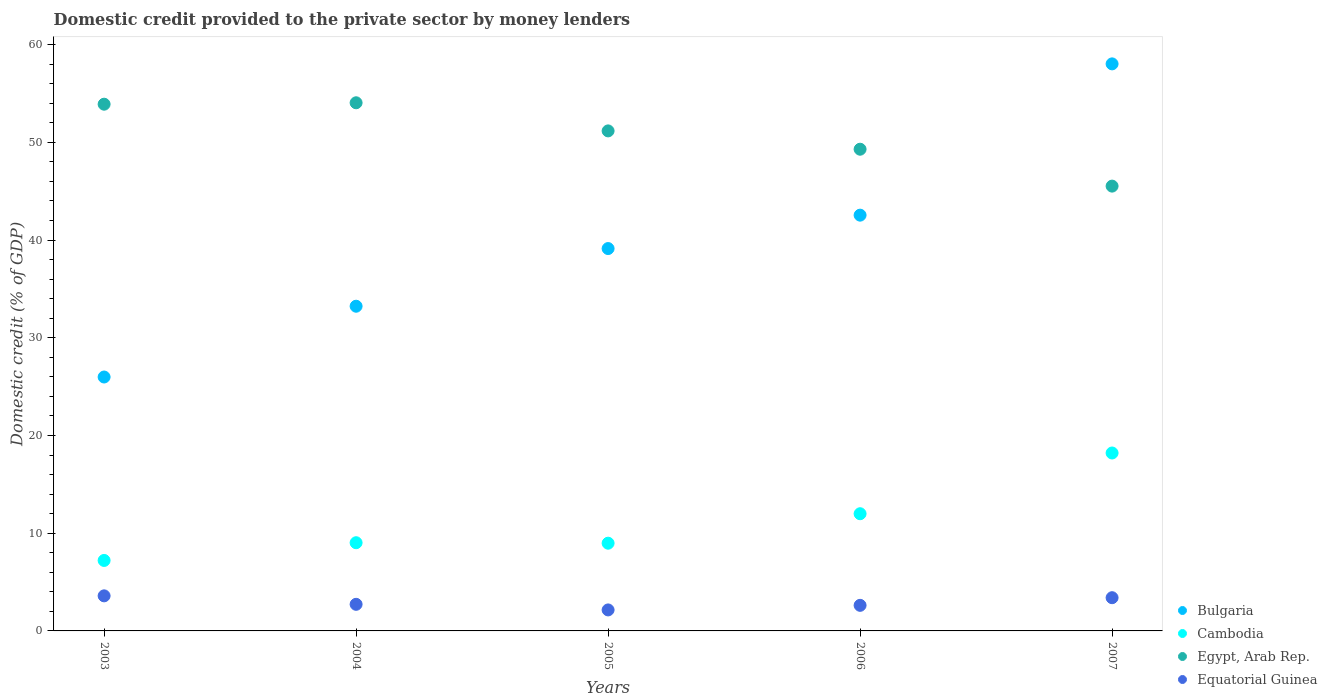How many different coloured dotlines are there?
Keep it short and to the point. 4. What is the domestic credit provided to the private sector by money lenders in Egypt, Arab Rep. in 2006?
Ensure brevity in your answer.  49.29. Across all years, what is the maximum domestic credit provided to the private sector by money lenders in Equatorial Guinea?
Your response must be concise. 3.59. Across all years, what is the minimum domestic credit provided to the private sector by money lenders in Cambodia?
Your answer should be very brief. 7.21. What is the total domestic credit provided to the private sector by money lenders in Equatorial Guinea in the graph?
Provide a succinct answer. 14.48. What is the difference between the domestic credit provided to the private sector by money lenders in Cambodia in 2004 and that in 2007?
Provide a short and direct response. -9.18. What is the difference between the domestic credit provided to the private sector by money lenders in Equatorial Guinea in 2005 and the domestic credit provided to the private sector by money lenders in Cambodia in 2007?
Provide a short and direct response. -16.06. What is the average domestic credit provided to the private sector by money lenders in Equatorial Guinea per year?
Provide a succinct answer. 2.9. In the year 2005, what is the difference between the domestic credit provided to the private sector by money lenders in Cambodia and domestic credit provided to the private sector by money lenders in Egypt, Arab Rep.?
Your answer should be very brief. -42.19. What is the ratio of the domestic credit provided to the private sector by money lenders in Equatorial Guinea in 2003 to that in 2005?
Offer a terse response. 1.67. Is the difference between the domestic credit provided to the private sector by money lenders in Cambodia in 2006 and 2007 greater than the difference between the domestic credit provided to the private sector by money lenders in Egypt, Arab Rep. in 2006 and 2007?
Your answer should be very brief. No. What is the difference between the highest and the second highest domestic credit provided to the private sector by money lenders in Egypt, Arab Rep.?
Your answer should be very brief. 0.15. What is the difference between the highest and the lowest domestic credit provided to the private sector by money lenders in Cambodia?
Offer a terse response. 11. Is it the case that in every year, the sum of the domestic credit provided to the private sector by money lenders in Cambodia and domestic credit provided to the private sector by money lenders in Equatorial Guinea  is greater than the sum of domestic credit provided to the private sector by money lenders in Egypt, Arab Rep. and domestic credit provided to the private sector by money lenders in Bulgaria?
Ensure brevity in your answer.  No. Is it the case that in every year, the sum of the domestic credit provided to the private sector by money lenders in Equatorial Guinea and domestic credit provided to the private sector by money lenders in Cambodia  is greater than the domestic credit provided to the private sector by money lenders in Egypt, Arab Rep.?
Your answer should be very brief. No. Is the domestic credit provided to the private sector by money lenders in Egypt, Arab Rep. strictly greater than the domestic credit provided to the private sector by money lenders in Cambodia over the years?
Give a very brief answer. Yes. How many dotlines are there?
Ensure brevity in your answer.  4. What is the difference between two consecutive major ticks on the Y-axis?
Your response must be concise. 10. Are the values on the major ticks of Y-axis written in scientific E-notation?
Provide a short and direct response. No. How are the legend labels stacked?
Offer a very short reply. Vertical. What is the title of the graph?
Offer a terse response. Domestic credit provided to the private sector by money lenders. Does "Yemen, Rep." appear as one of the legend labels in the graph?
Provide a short and direct response. No. What is the label or title of the X-axis?
Offer a very short reply. Years. What is the label or title of the Y-axis?
Keep it short and to the point. Domestic credit (% of GDP). What is the Domestic credit (% of GDP) in Bulgaria in 2003?
Your response must be concise. 25.98. What is the Domestic credit (% of GDP) of Cambodia in 2003?
Keep it short and to the point. 7.21. What is the Domestic credit (% of GDP) in Egypt, Arab Rep. in 2003?
Offer a very short reply. 53.9. What is the Domestic credit (% of GDP) of Equatorial Guinea in 2003?
Provide a succinct answer. 3.59. What is the Domestic credit (% of GDP) in Bulgaria in 2004?
Offer a terse response. 33.23. What is the Domestic credit (% of GDP) of Cambodia in 2004?
Provide a succinct answer. 9.02. What is the Domestic credit (% of GDP) in Egypt, Arab Rep. in 2004?
Make the answer very short. 54.04. What is the Domestic credit (% of GDP) of Equatorial Guinea in 2004?
Your response must be concise. 2.72. What is the Domestic credit (% of GDP) in Bulgaria in 2005?
Your answer should be compact. 39.13. What is the Domestic credit (% of GDP) of Cambodia in 2005?
Your answer should be compact. 8.98. What is the Domestic credit (% of GDP) in Egypt, Arab Rep. in 2005?
Make the answer very short. 51.17. What is the Domestic credit (% of GDP) in Equatorial Guinea in 2005?
Keep it short and to the point. 2.15. What is the Domestic credit (% of GDP) in Bulgaria in 2006?
Your answer should be very brief. 42.54. What is the Domestic credit (% of GDP) in Cambodia in 2006?
Keep it short and to the point. 11.99. What is the Domestic credit (% of GDP) of Egypt, Arab Rep. in 2006?
Your response must be concise. 49.29. What is the Domestic credit (% of GDP) of Equatorial Guinea in 2006?
Give a very brief answer. 2.62. What is the Domestic credit (% of GDP) of Bulgaria in 2007?
Your answer should be very brief. 58.02. What is the Domestic credit (% of GDP) in Cambodia in 2007?
Your answer should be compact. 18.21. What is the Domestic credit (% of GDP) of Egypt, Arab Rep. in 2007?
Keep it short and to the point. 45.52. What is the Domestic credit (% of GDP) of Equatorial Guinea in 2007?
Your response must be concise. 3.4. Across all years, what is the maximum Domestic credit (% of GDP) of Bulgaria?
Offer a very short reply. 58.02. Across all years, what is the maximum Domestic credit (% of GDP) of Cambodia?
Your answer should be very brief. 18.21. Across all years, what is the maximum Domestic credit (% of GDP) in Egypt, Arab Rep.?
Give a very brief answer. 54.04. Across all years, what is the maximum Domestic credit (% of GDP) in Equatorial Guinea?
Make the answer very short. 3.59. Across all years, what is the minimum Domestic credit (% of GDP) in Bulgaria?
Give a very brief answer. 25.98. Across all years, what is the minimum Domestic credit (% of GDP) of Cambodia?
Your answer should be compact. 7.21. Across all years, what is the minimum Domestic credit (% of GDP) in Egypt, Arab Rep.?
Make the answer very short. 45.52. Across all years, what is the minimum Domestic credit (% of GDP) in Equatorial Guinea?
Offer a very short reply. 2.15. What is the total Domestic credit (% of GDP) in Bulgaria in the graph?
Provide a succinct answer. 198.9. What is the total Domestic credit (% of GDP) in Cambodia in the graph?
Provide a short and direct response. 55.41. What is the total Domestic credit (% of GDP) of Egypt, Arab Rep. in the graph?
Provide a succinct answer. 253.91. What is the total Domestic credit (% of GDP) in Equatorial Guinea in the graph?
Your answer should be very brief. 14.48. What is the difference between the Domestic credit (% of GDP) in Bulgaria in 2003 and that in 2004?
Give a very brief answer. -7.24. What is the difference between the Domestic credit (% of GDP) in Cambodia in 2003 and that in 2004?
Ensure brevity in your answer.  -1.81. What is the difference between the Domestic credit (% of GDP) in Egypt, Arab Rep. in 2003 and that in 2004?
Make the answer very short. -0.15. What is the difference between the Domestic credit (% of GDP) in Equatorial Guinea in 2003 and that in 2004?
Make the answer very short. 0.87. What is the difference between the Domestic credit (% of GDP) of Bulgaria in 2003 and that in 2005?
Provide a succinct answer. -13.14. What is the difference between the Domestic credit (% of GDP) of Cambodia in 2003 and that in 2005?
Your answer should be compact. -1.76. What is the difference between the Domestic credit (% of GDP) of Egypt, Arab Rep. in 2003 and that in 2005?
Offer a terse response. 2.73. What is the difference between the Domestic credit (% of GDP) of Equatorial Guinea in 2003 and that in 2005?
Offer a very short reply. 1.44. What is the difference between the Domestic credit (% of GDP) of Bulgaria in 2003 and that in 2006?
Your answer should be compact. -16.56. What is the difference between the Domestic credit (% of GDP) in Cambodia in 2003 and that in 2006?
Offer a terse response. -4.78. What is the difference between the Domestic credit (% of GDP) in Egypt, Arab Rep. in 2003 and that in 2006?
Your response must be concise. 4.61. What is the difference between the Domestic credit (% of GDP) of Equatorial Guinea in 2003 and that in 2006?
Your answer should be very brief. 0.97. What is the difference between the Domestic credit (% of GDP) of Bulgaria in 2003 and that in 2007?
Your answer should be compact. -32.04. What is the difference between the Domestic credit (% of GDP) of Cambodia in 2003 and that in 2007?
Offer a terse response. -11. What is the difference between the Domestic credit (% of GDP) of Egypt, Arab Rep. in 2003 and that in 2007?
Keep it short and to the point. 8.38. What is the difference between the Domestic credit (% of GDP) in Equatorial Guinea in 2003 and that in 2007?
Keep it short and to the point. 0.19. What is the difference between the Domestic credit (% of GDP) in Bulgaria in 2004 and that in 2005?
Provide a succinct answer. -5.9. What is the difference between the Domestic credit (% of GDP) in Cambodia in 2004 and that in 2005?
Provide a succinct answer. 0.05. What is the difference between the Domestic credit (% of GDP) of Egypt, Arab Rep. in 2004 and that in 2005?
Your response must be concise. 2.88. What is the difference between the Domestic credit (% of GDP) in Equatorial Guinea in 2004 and that in 2005?
Offer a terse response. 0.57. What is the difference between the Domestic credit (% of GDP) in Bulgaria in 2004 and that in 2006?
Provide a short and direct response. -9.32. What is the difference between the Domestic credit (% of GDP) in Cambodia in 2004 and that in 2006?
Provide a succinct answer. -2.97. What is the difference between the Domestic credit (% of GDP) in Egypt, Arab Rep. in 2004 and that in 2006?
Provide a short and direct response. 4.75. What is the difference between the Domestic credit (% of GDP) of Equatorial Guinea in 2004 and that in 2006?
Provide a succinct answer. 0.1. What is the difference between the Domestic credit (% of GDP) in Bulgaria in 2004 and that in 2007?
Provide a short and direct response. -24.8. What is the difference between the Domestic credit (% of GDP) in Cambodia in 2004 and that in 2007?
Provide a short and direct response. -9.18. What is the difference between the Domestic credit (% of GDP) in Egypt, Arab Rep. in 2004 and that in 2007?
Ensure brevity in your answer.  8.53. What is the difference between the Domestic credit (% of GDP) of Equatorial Guinea in 2004 and that in 2007?
Your response must be concise. -0.68. What is the difference between the Domestic credit (% of GDP) in Bulgaria in 2005 and that in 2006?
Your answer should be compact. -3.42. What is the difference between the Domestic credit (% of GDP) of Cambodia in 2005 and that in 2006?
Make the answer very short. -3.02. What is the difference between the Domestic credit (% of GDP) of Egypt, Arab Rep. in 2005 and that in 2006?
Provide a short and direct response. 1.87. What is the difference between the Domestic credit (% of GDP) of Equatorial Guinea in 2005 and that in 2006?
Provide a succinct answer. -0.47. What is the difference between the Domestic credit (% of GDP) of Bulgaria in 2005 and that in 2007?
Ensure brevity in your answer.  -18.9. What is the difference between the Domestic credit (% of GDP) in Cambodia in 2005 and that in 2007?
Keep it short and to the point. -9.23. What is the difference between the Domestic credit (% of GDP) of Egypt, Arab Rep. in 2005 and that in 2007?
Your answer should be compact. 5.65. What is the difference between the Domestic credit (% of GDP) of Equatorial Guinea in 2005 and that in 2007?
Offer a very short reply. -1.25. What is the difference between the Domestic credit (% of GDP) in Bulgaria in 2006 and that in 2007?
Make the answer very short. -15.48. What is the difference between the Domestic credit (% of GDP) of Cambodia in 2006 and that in 2007?
Your answer should be compact. -6.21. What is the difference between the Domestic credit (% of GDP) of Egypt, Arab Rep. in 2006 and that in 2007?
Your response must be concise. 3.78. What is the difference between the Domestic credit (% of GDP) in Equatorial Guinea in 2006 and that in 2007?
Give a very brief answer. -0.78. What is the difference between the Domestic credit (% of GDP) of Bulgaria in 2003 and the Domestic credit (% of GDP) of Cambodia in 2004?
Offer a terse response. 16.96. What is the difference between the Domestic credit (% of GDP) of Bulgaria in 2003 and the Domestic credit (% of GDP) of Egypt, Arab Rep. in 2004?
Your response must be concise. -28.06. What is the difference between the Domestic credit (% of GDP) of Bulgaria in 2003 and the Domestic credit (% of GDP) of Equatorial Guinea in 2004?
Offer a very short reply. 23.26. What is the difference between the Domestic credit (% of GDP) in Cambodia in 2003 and the Domestic credit (% of GDP) in Egypt, Arab Rep. in 2004?
Make the answer very short. -46.83. What is the difference between the Domestic credit (% of GDP) in Cambodia in 2003 and the Domestic credit (% of GDP) in Equatorial Guinea in 2004?
Make the answer very short. 4.49. What is the difference between the Domestic credit (% of GDP) in Egypt, Arab Rep. in 2003 and the Domestic credit (% of GDP) in Equatorial Guinea in 2004?
Your answer should be compact. 51.18. What is the difference between the Domestic credit (% of GDP) of Bulgaria in 2003 and the Domestic credit (% of GDP) of Cambodia in 2005?
Offer a terse response. 17.01. What is the difference between the Domestic credit (% of GDP) in Bulgaria in 2003 and the Domestic credit (% of GDP) in Egypt, Arab Rep. in 2005?
Your response must be concise. -25.18. What is the difference between the Domestic credit (% of GDP) in Bulgaria in 2003 and the Domestic credit (% of GDP) in Equatorial Guinea in 2005?
Offer a terse response. 23.83. What is the difference between the Domestic credit (% of GDP) in Cambodia in 2003 and the Domestic credit (% of GDP) in Egypt, Arab Rep. in 2005?
Ensure brevity in your answer.  -43.95. What is the difference between the Domestic credit (% of GDP) in Cambodia in 2003 and the Domestic credit (% of GDP) in Equatorial Guinea in 2005?
Ensure brevity in your answer.  5.06. What is the difference between the Domestic credit (% of GDP) of Egypt, Arab Rep. in 2003 and the Domestic credit (% of GDP) of Equatorial Guinea in 2005?
Offer a terse response. 51.75. What is the difference between the Domestic credit (% of GDP) of Bulgaria in 2003 and the Domestic credit (% of GDP) of Cambodia in 2006?
Ensure brevity in your answer.  13.99. What is the difference between the Domestic credit (% of GDP) of Bulgaria in 2003 and the Domestic credit (% of GDP) of Egypt, Arab Rep. in 2006?
Offer a very short reply. -23.31. What is the difference between the Domestic credit (% of GDP) of Bulgaria in 2003 and the Domestic credit (% of GDP) of Equatorial Guinea in 2006?
Your response must be concise. 23.36. What is the difference between the Domestic credit (% of GDP) in Cambodia in 2003 and the Domestic credit (% of GDP) in Egypt, Arab Rep. in 2006?
Make the answer very short. -42.08. What is the difference between the Domestic credit (% of GDP) of Cambodia in 2003 and the Domestic credit (% of GDP) of Equatorial Guinea in 2006?
Your answer should be very brief. 4.59. What is the difference between the Domestic credit (% of GDP) of Egypt, Arab Rep. in 2003 and the Domestic credit (% of GDP) of Equatorial Guinea in 2006?
Keep it short and to the point. 51.28. What is the difference between the Domestic credit (% of GDP) of Bulgaria in 2003 and the Domestic credit (% of GDP) of Cambodia in 2007?
Your response must be concise. 7.77. What is the difference between the Domestic credit (% of GDP) in Bulgaria in 2003 and the Domestic credit (% of GDP) in Egypt, Arab Rep. in 2007?
Your response must be concise. -19.53. What is the difference between the Domestic credit (% of GDP) in Bulgaria in 2003 and the Domestic credit (% of GDP) in Equatorial Guinea in 2007?
Make the answer very short. 22.58. What is the difference between the Domestic credit (% of GDP) of Cambodia in 2003 and the Domestic credit (% of GDP) of Egypt, Arab Rep. in 2007?
Make the answer very short. -38.3. What is the difference between the Domestic credit (% of GDP) in Cambodia in 2003 and the Domestic credit (% of GDP) in Equatorial Guinea in 2007?
Keep it short and to the point. 3.81. What is the difference between the Domestic credit (% of GDP) in Egypt, Arab Rep. in 2003 and the Domestic credit (% of GDP) in Equatorial Guinea in 2007?
Offer a very short reply. 50.5. What is the difference between the Domestic credit (% of GDP) in Bulgaria in 2004 and the Domestic credit (% of GDP) in Cambodia in 2005?
Provide a short and direct response. 24.25. What is the difference between the Domestic credit (% of GDP) in Bulgaria in 2004 and the Domestic credit (% of GDP) in Egypt, Arab Rep. in 2005?
Provide a short and direct response. -17.94. What is the difference between the Domestic credit (% of GDP) of Bulgaria in 2004 and the Domestic credit (% of GDP) of Equatorial Guinea in 2005?
Your answer should be compact. 31.08. What is the difference between the Domestic credit (% of GDP) in Cambodia in 2004 and the Domestic credit (% of GDP) in Egypt, Arab Rep. in 2005?
Your response must be concise. -42.14. What is the difference between the Domestic credit (% of GDP) of Cambodia in 2004 and the Domestic credit (% of GDP) of Equatorial Guinea in 2005?
Provide a short and direct response. 6.88. What is the difference between the Domestic credit (% of GDP) in Egypt, Arab Rep. in 2004 and the Domestic credit (% of GDP) in Equatorial Guinea in 2005?
Provide a succinct answer. 51.89. What is the difference between the Domestic credit (% of GDP) in Bulgaria in 2004 and the Domestic credit (% of GDP) in Cambodia in 2006?
Your answer should be compact. 21.23. What is the difference between the Domestic credit (% of GDP) of Bulgaria in 2004 and the Domestic credit (% of GDP) of Egypt, Arab Rep. in 2006?
Provide a short and direct response. -16.07. What is the difference between the Domestic credit (% of GDP) in Bulgaria in 2004 and the Domestic credit (% of GDP) in Equatorial Guinea in 2006?
Your response must be concise. 30.61. What is the difference between the Domestic credit (% of GDP) of Cambodia in 2004 and the Domestic credit (% of GDP) of Egypt, Arab Rep. in 2006?
Keep it short and to the point. -40.27. What is the difference between the Domestic credit (% of GDP) in Cambodia in 2004 and the Domestic credit (% of GDP) in Equatorial Guinea in 2006?
Provide a succinct answer. 6.41. What is the difference between the Domestic credit (% of GDP) in Egypt, Arab Rep. in 2004 and the Domestic credit (% of GDP) in Equatorial Guinea in 2006?
Give a very brief answer. 51.43. What is the difference between the Domestic credit (% of GDP) in Bulgaria in 2004 and the Domestic credit (% of GDP) in Cambodia in 2007?
Ensure brevity in your answer.  15.02. What is the difference between the Domestic credit (% of GDP) of Bulgaria in 2004 and the Domestic credit (% of GDP) of Egypt, Arab Rep. in 2007?
Offer a terse response. -12.29. What is the difference between the Domestic credit (% of GDP) in Bulgaria in 2004 and the Domestic credit (% of GDP) in Equatorial Guinea in 2007?
Your response must be concise. 29.83. What is the difference between the Domestic credit (% of GDP) of Cambodia in 2004 and the Domestic credit (% of GDP) of Egypt, Arab Rep. in 2007?
Offer a very short reply. -36.49. What is the difference between the Domestic credit (% of GDP) of Cambodia in 2004 and the Domestic credit (% of GDP) of Equatorial Guinea in 2007?
Offer a very short reply. 5.63. What is the difference between the Domestic credit (% of GDP) of Egypt, Arab Rep. in 2004 and the Domestic credit (% of GDP) of Equatorial Guinea in 2007?
Your answer should be compact. 50.64. What is the difference between the Domestic credit (% of GDP) in Bulgaria in 2005 and the Domestic credit (% of GDP) in Cambodia in 2006?
Offer a very short reply. 27.13. What is the difference between the Domestic credit (% of GDP) in Bulgaria in 2005 and the Domestic credit (% of GDP) in Egypt, Arab Rep. in 2006?
Provide a succinct answer. -10.17. What is the difference between the Domestic credit (% of GDP) of Bulgaria in 2005 and the Domestic credit (% of GDP) of Equatorial Guinea in 2006?
Offer a very short reply. 36.51. What is the difference between the Domestic credit (% of GDP) of Cambodia in 2005 and the Domestic credit (% of GDP) of Egypt, Arab Rep. in 2006?
Offer a terse response. -40.31. What is the difference between the Domestic credit (% of GDP) of Cambodia in 2005 and the Domestic credit (% of GDP) of Equatorial Guinea in 2006?
Offer a terse response. 6.36. What is the difference between the Domestic credit (% of GDP) in Egypt, Arab Rep. in 2005 and the Domestic credit (% of GDP) in Equatorial Guinea in 2006?
Your answer should be compact. 48.55. What is the difference between the Domestic credit (% of GDP) in Bulgaria in 2005 and the Domestic credit (% of GDP) in Cambodia in 2007?
Offer a terse response. 20.92. What is the difference between the Domestic credit (% of GDP) of Bulgaria in 2005 and the Domestic credit (% of GDP) of Egypt, Arab Rep. in 2007?
Provide a short and direct response. -6.39. What is the difference between the Domestic credit (% of GDP) of Bulgaria in 2005 and the Domestic credit (% of GDP) of Equatorial Guinea in 2007?
Keep it short and to the point. 35.73. What is the difference between the Domestic credit (% of GDP) of Cambodia in 2005 and the Domestic credit (% of GDP) of Egypt, Arab Rep. in 2007?
Provide a succinct answer. -36.54. What is the difference between the Domestic credit (% of GDP) in Cambodia in 2005 and the Domestic credit (% of GDP) in Equatorial Guinea in 2007?
Your answer should be very brief. 5.58. What is the difference between the Domestic credit (% of GDP) of Egypt, Arab Rep. in 2005 and the Domestic credit (% of GDP) of Equatorial Guinea in 2007?
Give a very brief answer. 47.77. What is the difference between the Domestic credit (% of GDP) of Bulgaria in 2006 and the Domestic credit (% of GDP) of Cambodia in 2007?
Provide a short and direct response. 24.34. What is the difference between the Domestic credit (% of GDP) of Bulgaria in 2006 and the Domestic credit (% of GDP) of Egypt, Arab Rep. in 2007?
Your response must be concise. -2.97. What is the difference between the Domestic credit (% of GDP) in Bulgaria in 2006 and the Domestic credit (% of GDP) in Equatorial Guinea in 2007?
Give a very brief answer. 39.14. What is the difference between the Domestic credit (% of GDP) of Cambodia in 2006 and the Domestic credit (% of GDP) of Egypt, Arab Rep. in 2007?
Provide a succinct answer. -33.52. What is the difference between the Domestic credit (% of GDP) of Cambodia in 2006 and the Domestic credit (% of GDP) of Equatorial Guinea in 2007?
Provide a succinct answer. 8.59. What is the difference between the Domestic credit (% of GDP) of Egypt, Arab Rep. in 2006 and the Domestic credit (% of GDP) of Equatorial Guinea in 2007?
Your answer should be very brief. 45.89. What is the average Domestic credit (% of GDP) of Bulgaria per year?
Make the answer very short. 39.78. What is the average Domestic credit (% of GDP) in Cambodia per year?
Provide a succinct answer. 11.08. What is the average Domestic credit (% of GDP) of Egypt, Arab Rep. per year?
Keep it short and to the point. 50.78. What is the average Domestic credit (% of GDP) in Equatorial Guinea per year?
Offer a terse response. 2.9. In the year 2003, what is the difference between the Domestic credit (% of GDP) in Bulgaria and Domestic credit (% of GDP) in Cambodia?
Offer a terse response. 18.77. In the year 2003, what is the difference between the Domestic credit (% of GDP) of Bulgaria and Domestic credit (% of GDP) of Egypt, Arab Rep.?
Your answer should be very brief. -27.92. In the year 2003, what is the difference between the Domestic credit (% of GDP) in Bulgaria and Domestic credit (% of GDP) in Equatorial Guinea?
Your answer should be compact. 22.39. In the year 2003, what is the difference between the Domestic credit (% of GDP) of Cambodia and Domestic credit (% of GDP) of Egypt, Arab Rep.?
Provide a short and direct response. -46.69. In the year 2003, what is the difference between the Domestic credit (% of GDP) in Cambodia and Domestic credit (% of GDP) in Equatorial Guinea?
Your answer should be very brief. 3.62. In the year 2003, what is the difference between the Domestic credit (% of GDP) of Egypt, Arab Rep. and Domestic credit (% of GDP) of Equatorial Guinea?
Offer a terse response. 50.31. In the year 2004, what is the difference between the Domestic credit (% of GDP) of Bulgaria and Domestic credit (% of GDP) of Cambodia?
Keep it short and to the point. 24.2. In the year 2004, what is the difference between the Domestic credit (% of GDP) in Bulgaria and Domestic credit (% of GDP) in Egypt, Arab Rep.?
Your answer should be compact. -20.82. In the year 2004, what is the difference between the Domestic credit (% of GDP) in Bulgaria and Domestic credit (% of GDP) in Equatorial Guinea?
Make the answer very short. 30.5. In the year 2004, what is the difference between the Domestic credit (% of GDP) of Cambodia and Domestic credit (% of GDP) of Egypt, Arab Rep.?
Give a very brief answer. -45.02. In the year 2004, what is the difference between the Domestic credit (% of GDP) of Cambodia and Domestic credit (% of GDP) of Equatorial Guinea?
Make the answer very short. 6.3. In the year 2004, what is the difference between the Domestic credit (% of GDP) of Egypt, Arab Rep. and Domestic credit (% of GDP) of Equatorial Guinea?
Offer a very short reply. 51.32. In the year 2005, what is the difference between the Domestic credit (% of GDP) of Bulgaria and Domestic credit (% of GDP) of Cambodia?
Your answer should be very brief. 30.15. In the year 2005, what is the difference between the Domestic credit (% of GDP) in Bulgaria and Domestic credit (% of GDP) in Egypt, Arab Rep.?
Make the answer very short. -12.04. In the year 2005, what is the difference between the Domestic credit (% of GDP) of Bulgaria and Domestic credit (% of GDP) of Equatorial Guinea?
Give a very brief answer. 36.98. In the year 2005, what is the difference between the Domestic credit (% of GDP) of Cambodia and Domestic credit (% of GDP) of Egypt, Arab Rep.?
Your answer should be compact. -42.19. In the year 2005, what is the difference between the Domestic credit (% of GDP) in Cambodia and Domestic credit (% of GDP) in Equatorial Guinea?
Keep it short and to the point. 6.83. In the year 2005, what is the difference between the Domestic credit (% of GDP) of Egypt, Arab Rep. and Domestic credit (% of GDP) of Equatorial Guinea?
Your response must be concise. 49.02. In the year 2006, what is the difference between the Domestic credit (% of GDP) of Bulgaria and Domestic credit (% of GDP) of Cambodia?
Your answer should be very brief. 30.55. In the year 2006, what is the difference between the Domestic credit (% of GDP) in Bulgaria and Domestic credit (% of GDP) in Egypt, Arab Rep.?
Make the answer very short. -6.75. In the year 2006, what is the difference between the Domestic credit (% of GDP) in Bulgaria and Domestic credit (% of GDP) in Equatorial Guinea?
Your answer should be very brief. 39.93. In the year 2006, what is the difference between the Domestic credit (% of GDP) of Cambodia and Domestic credit (% of GDP) of Egypt, Arab Rep.?
Provide a succinct answer. -37.3. In the year 2006, what is the difference between the Domestic credit (% of GDP) in Cambodia and Domestic credit (% of GDP) in Equatorial Guinea?
Keep it short and to the point. 9.38. In the year 2006, what is the difference between the Domestic credit (% of GDP) of Egypt, Arab Rep. and Domestic credit (% of GDP) of Equatorial Guinea?
Provide a short and direct response. 46.67. In the year 2007, what is the difference between the Domestic credit (% of GDP) in Bulgaria and Domestic credit (% of GDP) in Cambodia?
Provide a succinct answer. 39.82. In the year 2007, what is the difference between the Domestic credit (% of GDP) of Bulgaria and Domestic credit (% of GDP) of Egypt, Arab Rep.?
Your answer should be very brief. 12.51. In the year 2007, what is the difference between the Domestic credit (% of GDP) of Bulgaria and Domestic credit (% of GDP) of Equatorial Guinea?
Keep it short and to the point. 54.62. In the year 2007, what is the difference between the Domestic credit (% of GDP) in Cambodia and Domestic credit (% of GDP) in Egypt, Arab Rep.?
Your answer should be compact. -27.31. In the year 2007, what is the difference between the Domestic credit (% of GDP) of Cambodia and Domestic credit (% of GDP) of Equatorial Guinea?
Provide a succinct answer. 14.81. In the year 2007, what is the difference between the Domestic credit (% of GDP) in Egypt, Arab Rep. and Domestic credit (% of GDP) in Equatorial Guinea?
Your answer should be very brief. 42.12. What is the ratio of the Domestic credit (% of GDP) in Bulgaria in 2003 to that in 2004?
Provide a succinct answer. 0.78. What is the ratio of the Domestic credit (% of GDP) of Cambodia in 2003 to that in 2004?
Offer a terse response. 0.8. What is the ratio of the Domestic credit (% of GDP) in Equatorial Guinea in 2003 to that in 2004?
Make the answer very short. 1.32. What is the ratio of the Domestic credit (% of GDP) in Bulgaria in 2003 to that in 2005?
Provide a short and direct response. 0.66. What is the ratio of the Domestic credit (% of GDP) in Cambodia in 2003 to that in 2005?
Your answer should be compact. 0.8. What is the ratio of the Domestic credit (% of GDP) of Egypt, Arab Rep. in 2003 to that in 2005?
Make the answer very short. 1.05. What is the ratio of the Domestic credit (% of GDP) in Equatorial Guinea in 2003 to that in 2005?
Keep it short and to the point. 1.67. What is the ratio of the Domestic credit (% of GDP) in Bulgaria in 2003 to that in 2006?
Your answer should be compact. 0.61. What is the ratio of the Domestic credit (% of GDP) of Cambodia in 2003 to that in 2006?
Offer a very short reply. 0.6. What is the ratio of the Domestic credit (% of GDP) of Egypt, Arab Rep. in 2003 to that in 2006?
Your response must be concise. 1.09. What is the ratio of the Domestic credit (% of GDP) in Equatorial Guinea in 2003 to that in 2006?
Offer a terse response. 1.37. What is the ratio of the Domestic credit (% of GDP) of Bulgaria in 2003 to that in 2007?
Offer a terse response. 0.45. What is the ratio of the Domestic credit (% of GDP) in Cambodia in 2003 to that in 2007?
Offer a very short reply. 0.4. What is the ratio of the Domestic credit (% of GDP) in Egypt, Arab Rep. in 2003 to that in 2007?
Ensure brevity in your answer.  1.18. What is the ratio of the Domestic credit (% of GDP) of Equatorial Guinea in 2003 to that in 2007?
Ensure brevity in your answer.  1.06. What is the ratio of the Domestic credit (% of GDP) in Bulgaria in 2004 to that in 2005?
Make the answer very short. 0.85. What is the ratio of the Domestic credit (% of GDP) in Cambodia in 2004 to that in 2005?
Offer a very short reply. 1.01. What is the ratio of the Domestic credit (% of GDP) of Egypt, Arab Rep. in 2004 to that in 2005?
Provide a short and direct response. 1.06. What is the ratio of the Domestic credit (% of GDP) of Equatorial Guinea in 2004 to that in 2005?
Keep it short and to the point. 1.27. What is the ratio of the Domestic credit (% of GDP) in Bulgaria in 2004 to that in 2006?
Keep it short and to the point. 0.78. What is the ratio of the Domestic credit (% of GDP) of Cambodia in 2004 to that in 2006?
Provide a short and direct response. 0.75. What is the ratio of the Domestic credit (% of GDP) in Egypt, Arab Rep. in 2004 to that in 2006?
Your answer should be compact. 1.1. What is the ratio of the Domestic credit (% of GDP) in Equatorial Guinea in 2004 to that in 2006?
Offer a terse response. 1.04. What is the ratio of the Domestic credit (% of GDP) of Bulgaria in 2004 to that in 2007?
Your response must be concise. 0.57. What is the ratio of the Domestic credit (% of GDP) in Cambodia in 2004 to that in 2007?
Your answer should be very brief. 0.5. What is the ratio of the Domestic credit (% of GDP) in Egypt, Arab Rep. in 2004 to that in 2007?
Keep it short and to the point. 1.19. What is the ratio of the Domestic credit (% of GDP) of Equatorial Guinea in 2004 to that in 2007?
Provide a short and direct response. 0.8. What is the ratio of the Domestic credit (% of GDP) of Bulgaria in 2005 to that in 2006?
Your answer should be very brief. 0.92. What is the ratio of the Domestic credit (% of GDP) of Cambodia in 2005 to that in 2006?
Make the answer very short. 0.75. What is the ratio of the Domestic credit (% of GDP) of Egypt, Arab Rep. in 2005 to that in 2006?
Provide a short and direct response. 1.04. What is the ratio of the Domestic credit (% of GDP) in Equatorial Guinea in 2005 to that in 2006?
Make the answer very short. 0.82. What is the ratio of the Domestic credit (% of GDP) in Bulgaria in 2005 to that in 2007?
Offer a very short reply. 0.67. What is the ratio of the Domestic credit (% of GDP) of Cambodia in 2005 to that in 2007?
Your answer should be compact. 0.49. What is the ratio of the Domestic credit (% of GDP) in Egypt, Arab Rep. in 2005 to that in 2007?
Give a very brief answer. 1.12. What is the ratio of the Domestic credit (% of GDP) of Equatorial Guinea in 2005 to that in 2007?
Offer a very short reply. 0.63. What is the ratio of the Domestic credit (% of GDP) of Bulgaria in 2006 to that in 2007?
Offer a terse response. 0.73. What is the ratio of the Domestic credit (% of GDP) of Cambodia in 2006 to that in 2007?
Provide a short and direct response. 0.66. What is the ratio of the Domestic credit (% of GDP) of Egypt, Arab Rep. in 2006 to that in 2007?
Offer a terse response. 1.08. What is the ratio of the Domestic credit (% of GDP) in Equatorial Guinea in 2006 to that in 2007?
Give a very brief answer. 0.77. What is the difference between the highest and the second highest Domestic credit (% of GDP) in Bulgaria?
Make the answer very short. 15.48. What is the difference between the highest and the second highest Domestic credit (% of GDP) in Cambodia?
Offer a very short reply. 6.21. What is the difference between the highest and the second highest Domestic credit (% of GDP) of Egypt, Arab Rep.?
Provide a succinct answer. 0.15. What is the difference between the highest and the second highest Domestic credit (% of GDP) of Equatorial Guinea?
Offer a terse response. 0.19. What is the difference between the highest and the lowest Domestic credit (% of GDP) of Bulgaria?
Your answer should be compact. 32.04. What is the difference between the highest and the lowest Domestic credit (% of GDP) of Cambodia?
Ensure brevity in your answer.  11. What is the difference between the highest and the lowest Domestic credit (% of GDP) in Egypt, Arab Rep.?
Your answer should be very brief. 8.53. What is the difference between the highest and the lowest Domestic credit (% of GDP) of Equatorial Guinea?
Your answer should be very brief. 1.44. 